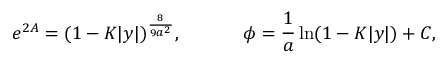<formula> <loc_0><loc_0><loc_500><loc_500>e ^ { 2 A } = ( 1 - K | y | ) ^ { \frac { 8 } { 9 a ^ { 2 } } } , \quad p h i = { \frac { 1 } { a } } \ln ( 1 - K | y | ) + C ,</formula> 